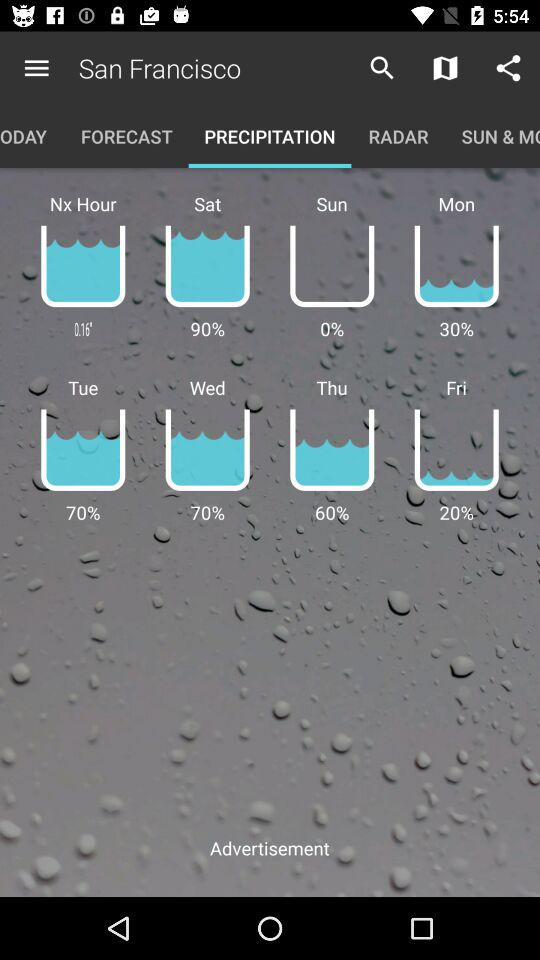What is the percentage of water on Friday? There is 20% water on Friday. 